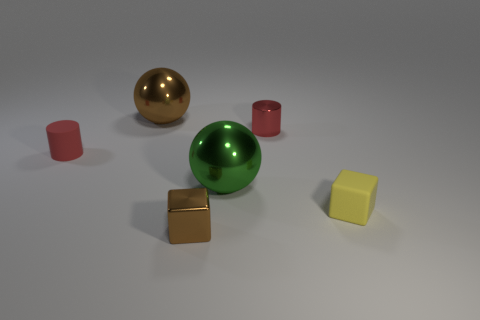Does the thing on the right side of the small red metallic object have the same material as the big green thing?
Give a very brief answer. No. The other tiny metallic thing that is the same shape as the small yellow thing is what color?
Provide a short and direct response. Brown. How many other objects are the same color as the metal cube?
Give a very brief answer. 1. There is a brown thing behind the big green metallic ball; does it have the same shape as the green thing that is on the right side of the brown metallic block?
Offer a terse response. Yes. What number of cylinders are either big green metal objects or big shiny things?
Ensure brevity in your answer.  0. Is the number of large objects behind the big brown metallic sphere less than the number of big cyan shiny spheres?
Give a very brief answer. No. What number of other things are made of the same material as the small yellow cube?
Give a very brief answer. 1. Does the red metal object have the same size as the brown metallic block?
Your answer should be compact. Yes. What number of objects are tiny objects that are behind the tiny yellow thing or small brown blocks?
Your answer should be compact. 3. What is the material of the red thing that is right of the large ball that is left of the brown metallic cube?
Provide a succinct answer. Metal. 